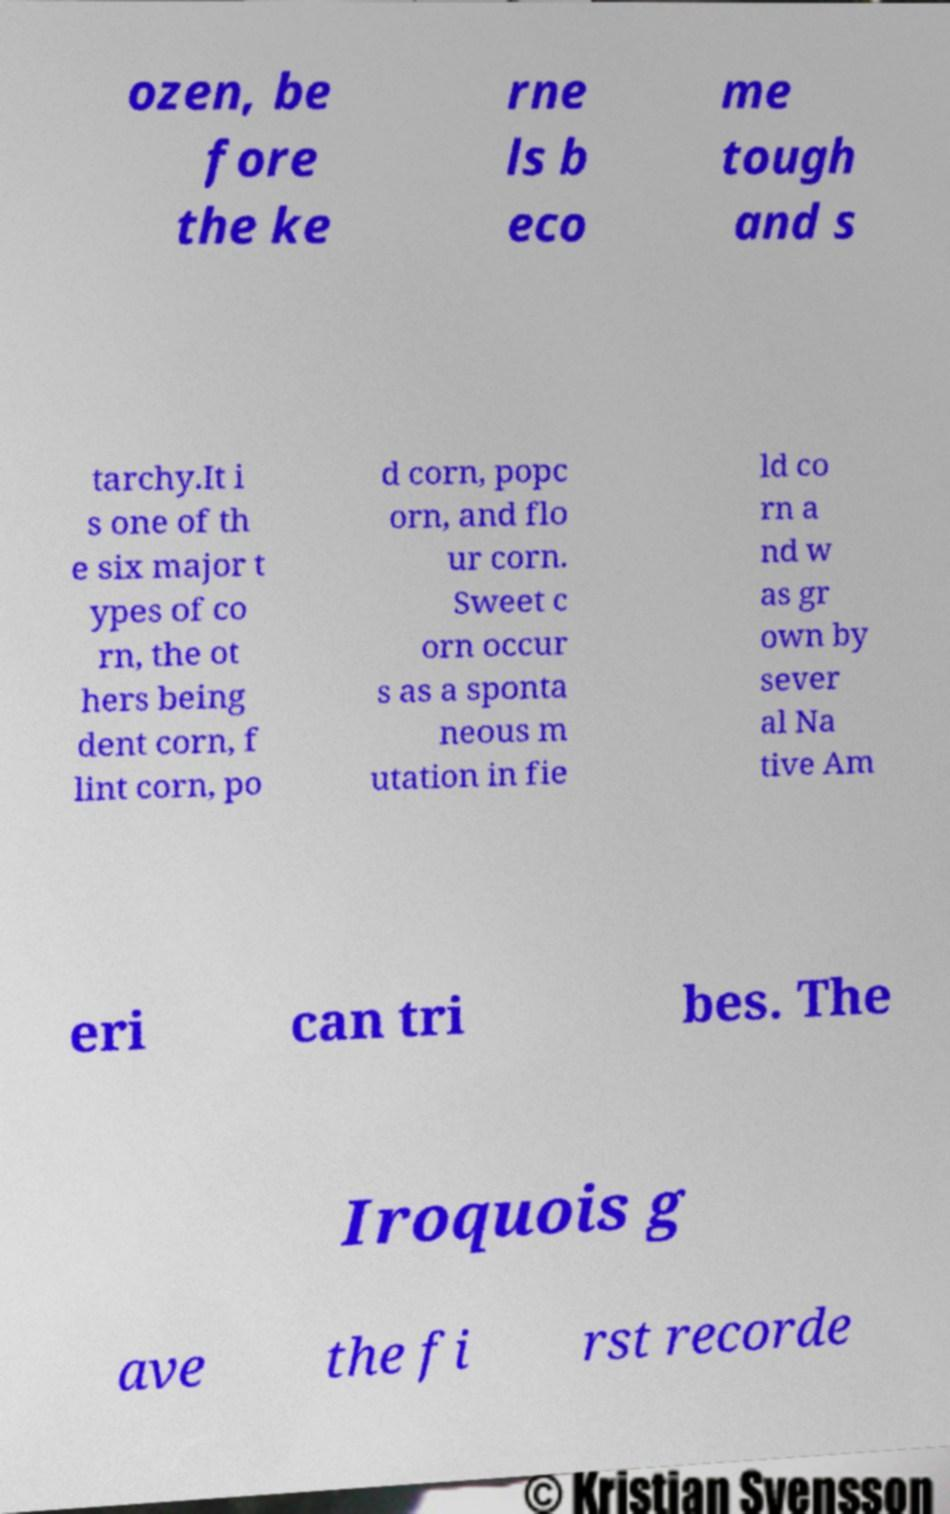What messages or text are displayed in this image? I need them in a readable, typed format. ozen, be fore the ke rne ls b eco me tough and s tarchy.It i s one of th e six major t ypes of co rn, the ot hers being dent corn, f lint corn, po d corn, popc orn, and flo ur corn. Sweet c orn occur s as a sponta neous m utation in fie ld co rn a nd w as gr own by sever al Na tive Am eri can tri bes. The Iroquois g ave the fi rst recorde 